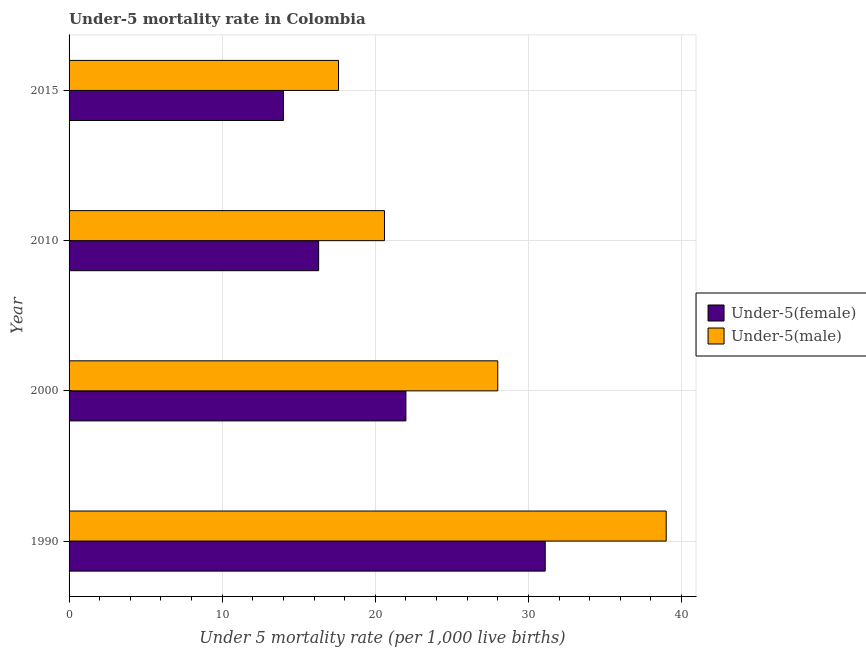How many different coloured bars are there?
Make the answer very short. 2. How many groups of bars are there?
Make the answer very short. 4. Are the number of bars on each tick of the Y-axis equal?
Your answer should be compact. Yes. How many bars are there on the 3rd tick from the top?
Make the answer very short. 2. How many bars are there on the 1st tick from the bottom?
Provide a succinct answer. 2. What is the label of the 1st group of bars from the top?
Keep it short and to the point. 2015. Across all years, what is the maximum under-5 male mortality rate?
Ensure brevity in your answer.  39. In which year was the under-5 male mortality rate maximum?
Your answer should be very brief. 1990. In which year was the under-5 male mortality rate minimum?
Your answer should be compact. 2015. What is the total under-5 female mortality rate in the graph?
Provide a short and direct response. 83.4. What is the difference between the under-5 male mortality rate in 1990 and that in 2010?
Your response must be concise. 18.4. What is the difference between the under-5 male mortality rate in 2010 and the under-5 female mortality rate in 2000?
Your answer should be compact. -1.4. What is the average under-5 male mortality rate per year?
Make the answer very short. 26.3. What is the ratio of the under-5 male mortality rate in 2010 to that in 2015?
Provide a succinct answer. 1.17. Is the under-5 female mortality rate in 2000 less than that in 2015?
Your answer should be compact. No. Is the difference between the under-5 male mortality rate in 1990 and 2010 greater than the difference between the under-5 female mortality rate in 1990 and 2010?
Give a very brief answer. Yes. What is the difference between the highest and the lowest under-5 male mortality rate?
Offer a terse response. 21.4. In how many years, is the under-5 female mortality rate greater than the average under-5 female mortality rate taken over all years?
Provide a succinct answer. 2. What does the 2nd bar from the top in 2010 represents?
Your answer should be very brief. Under-5(female). What does the 1st bar from the bottom in 1990 represents?
Your answer should be very brief. Under-5(female). How many bars are there?
Give a very brief answer. 8. Are all the bars in the graph horizontal?
Offer a very short reply. Yes. How many years are there in the graph?
Offer a very short reply. 4. Are the values on the major ticks of X-axis written in scientific E-notation?
Your response must be concise. No. Does the graph contain grids?
Your response must be concise. Yes. Where does the legend appear in the graph?
Keep it short and to the point. Center right. How many legend labels are there?
Ensure brevity in your answer.  2. What is the title of the graph?
Ensure brevity in your answer.  Under-5 mortality rate in Colombia. What is the label or title of the X-axis?
Your response must be concise. Under 5 mortality rate (per 1,0 live births). What is the label or title of the Y-axis?
Offer a terse response. Year. What is the Under 5 mortality rate (per 1,000 live births) in Under-5(female) in 1990?
Provide a succinct answer. 31.1. What is the Under 5 mortality rate (per 1,000 live births) in Under-5(male) in 1990?
Offer a terse response. 39. What is the Under 5 mortality rate (per 1,000 live births) in Under-5(male) in 2000?
Make the answer very short. 28. What is the Under 5 mortality rate (per 1,000 live births) of Under-5(female) in 2010?
Your answer should be very brief. 16.3. What is the Under 5 mortality rate (per 1,000 live births) of Under-5(male) in 2010?
Provide a short and direct response. 20.6. What is the Under 5 mortality rate (per 1,000 live births) in Under-5(male) in 2015?
Your response must be concise. 17.6. Across all years, what is the maximum Under 5 mortality rate (per 1,000 live births) of Under-5(female)?
Make the answer very short. 31.1. Across all years, what is the maximum Under 5 mortality rate (per 1,000 live births) of Under-5(male)?
Your answer should be compact. 39. Across all years, what is the minimum Under 5 mortality rate (per 1,000 live births) in Under-5(female)?
Offer a terse response. 14. Across all years, what is the minimum Under 5 mortality rate (per 1,000 live births) in Under-5(male)?
Make the answer very short. 17.6. What is the total Under 5 mortality rate (per 1,000 live births) in Under-5(female) in the graph?
Make the answer very short. 83.4. What is the total Under 5 mortality rate (per 1,000 live births) of Under-5(male) in the graph?
Offer a terse response. 105.2. What is the difference between the Under 5 mortality rate (per 1,000 live births) in Under-5(female) in 1990 and that in 2000?
Ensure brevity in your answer.  9.1. What is the difference between the Under 5 mortality rate (per 1,000 live births) of Under-5(male) in 1990 and that in 2000?
Offer a very short reply. 11. What is the difference between the Under 5 mortality rate (per 1,000 live births) of Under-5(female) in 1990 and that in 2010?
Offer a terse response. 14.8. What is the difference between the Under 5 mortality rate (per 1,000 live births) in Under-5(male) in 1990 and that in 2010?
Make the answer very short. 18.4. What is the difference between the Under 5 mortality rate (per 1,000 live births) in Under-5(female) in 1990 and that in 2015?
Give a very brief answer. 17.1. What is the difference between the Under 5 mortality rate (per 1,000 live births) of Under-5(male) in 1990 and that in 2015?
Your response must be concise. 21.4. What is the difference between the Under 5 mortality rate (per 1,000 live births) of Under-5(female) in 2000 and that in 2010?
Give a very brief answer. 5.7. What is the difference between the Under 5 mortality rate (per 1,000 live births) of Under-5(male) in 2000 and that in 2010?
Offer a very short reply. 7.4. What is the difference between the Under 5 mortality rate (per 1,000 live births) in Under-5(female) in 2000 and that in 2015?
Provide a succinct answer. 8. What is the difference between the Under 5 mortality rate (per 1,000 live births) in Under-5(male) in 2000 and that in 2015?
Give a very brief answer. 10.4. What is the difference between the Under 5 mortality rate (per 1,000 live births) in Under-5(female) in 2010 and that in 2015?
Keep it short and to the point. 2.3. What is the difference between the Under 5 mortality rate (per 1,000 live births) of Under-5(female) in 1990 and the Under 5 mortality rate (per 1,000 live births) of Under-5(male) in 2015?
Give a very brief answer. 13.5. What is the difference between the Under 5 mortality rate (per 1,000 live births) of Under-5(female) in 2000 and the Under 5 mortality rate (per 1,000 live births) of Under-5(male) in 2010?
Your response must be concise. 1.4. What is the average Under 5 mortality rate (per 1,000 live births) in Under-5(female) per year?
Give a very brief answer. 20.85. What is the average Under 5 mortality rate (per 1,000 live births) in Under-5(male) per year?
Provide a short and direct response. 26.3. In the year 1990, what is the difference between the Under 5 mortality rate (per 1,000 live births) in Under-5(female) and Under 5 mortality rate (per 1,000 live births) in Under-5(male)?
Your answer should be compact. -7.9. In the year 2010, what is the difference between the Under 5 mortality rate (per 1,000 live births) of Under-5(female) and Under 5 mortality rate (per 1,000 live births) of Under-5(male)?
Offer a very short reply. -4.3. What is the ratio of the Under 5 mortality rate (per 1,000 live births) of Under-5(female) in 1990 to that in 2000?
Provide a short and direct response. 1.41. What is the ratio of the Under 5 mortality rate (per 1,000 live births) of Under-5(male) in 1990 to that in 2000?
Your answer should be very brief. 1.39. What is the ratio of the Under 5 mortality rate (per 1,000 live births) of Under-5(female) in 1990 to that in 2010?
Make the answer very short. 1.91. What is the ratio of the Under 5 mortality rate (per 1,000 live births) in Under-5(male) in 1990 to that in 2010?
Keep it short and to the point. 1.89. What is the ratio of the Under 5 mortality rate (per 1,000 live births) of Under-5(female) in 1990 to that in 2015?
Your response must be concise. 2.22. What is the ratio of the Under 5 mortality rate (per 1,000 live births) of Under-5(male) in 1990 to that in 2015?
Your response must be concise. 2.22. What is the ratio of the Under 5 mortality rate (per 1,000 live births) in Under-5(female) in 2000 to that in 2010?
Give a very brief answer. 1.35. What is the ratio of the Under 5 mortality rate (per 1,000 live births) in Under-5(male) in 2000 to that in 2010?
Keep it short and to the point. 1.36. What is the ratio of the Under 5 mortality rate (per 1,000 live births) in Under-5(female) in 2000 to that in 2015?
Your answer should be very brief. 1.57. What is the ratio of the Under 5 mortality rate (per 1,000 live births) of Under-5(male) in 2000 to that in 2015?
Keep it short and to the point. 1.59. What is the ratio of the Under 5 mortality rate (per 1,000 live births) of Under-5(female) in 2010 to that in 2015?
Your response must be concise. 1.16. What is the ratio of the Under 5 mortality rate (per 1,000 live births) in Under-5(male) in 2010 to that in 2015?
Give a very brief answer. 1.17. What is the difference between the highest and the second highest Under 5 mortality rate (per 1,000 live births) in Under-5(female)?
Your answer should be very brief. 9.1. What is the difference between the highest and the second highest Under 5 mortality rate (per 1,000 live births) in Under-5(male)?
Make the answer very short. 11. What is the difference between the highest and the lowest Under 5 mortality rate (per 1,000 live births) of Under-5(female)?
Offer a very short reply. 17.1. What is the difference between the highest and the lowest Under 5 mortality rate (per 1,000 live births) of Under-5(male)?
Your response must be concise. 21.4. 